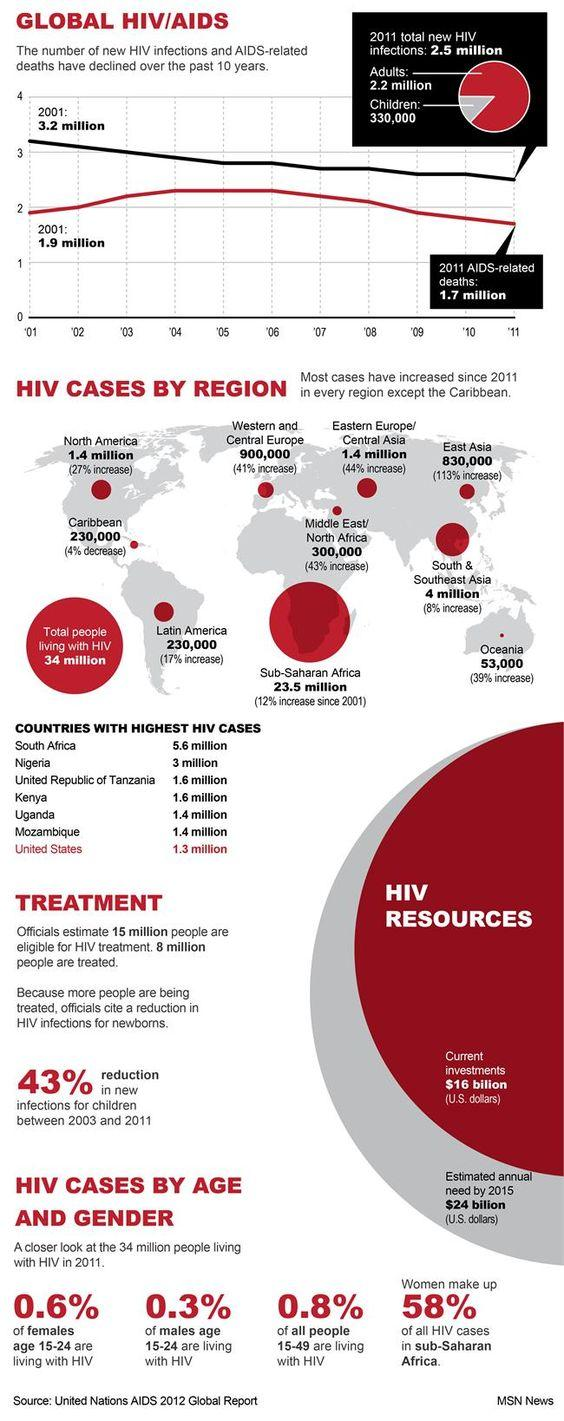Highlight a few significant elements in this photo. The total number in both the American continents is 1,860,000. From 2001 to 2011, the number of new HIV deaths declined by approximately 0.2 million. The ranking of Uganda in the list of countries with the highest number of HIV cases is not specified in the provided information. The regions of Caribbean and Latin America have the same number of case counts. Sub-Saharan Africa has the highest number of HIV cases, according to recent data. 